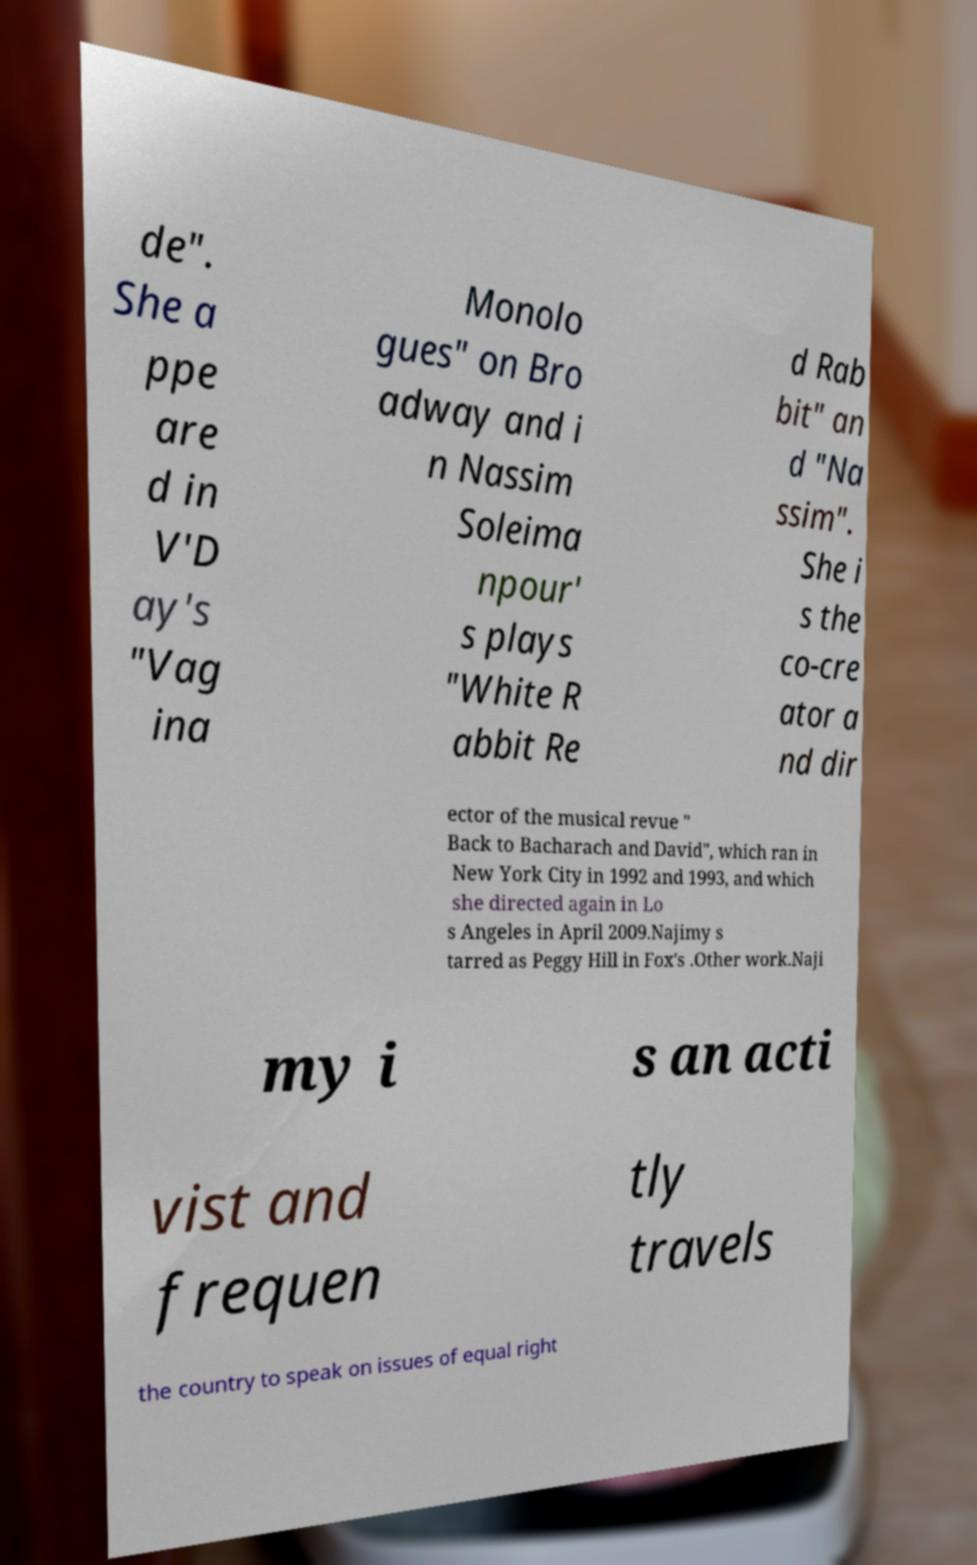Can you accurately transcribe the text from the provided image for me? de". She a ppe are d in V'D ay's "Vag ina Monolo gues" on Bro adway and i n Nassim Soleima npour' s plays "White R abbit Re d Rab bit" an d "Na ssim". She i s the co-cre ator a nd dir ector of the musical revue " Back to Bacharach and David", which ran in New York City in 1992 and 1993, and which she directed again in Lo s Angeles in April 2009.Najimy s tarred as Peggy Hill in Fox's .Other work.Naji my i s an acti vist and frequen tly travels the country to speak on issues of equal right 